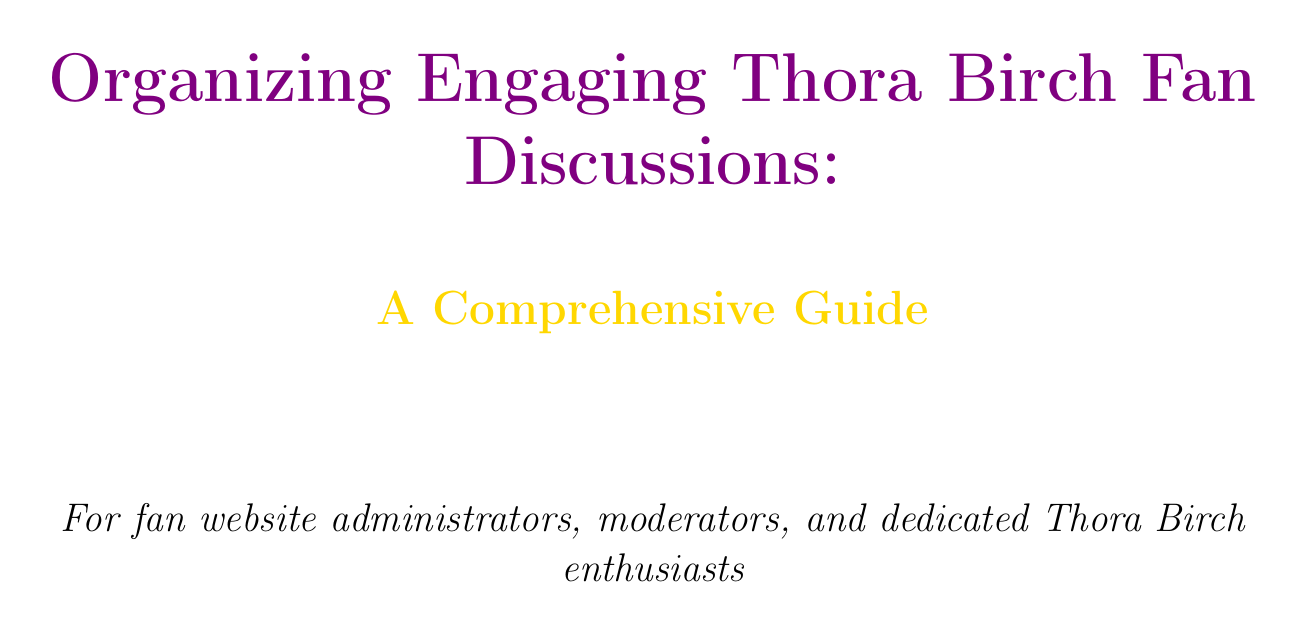what is the title of the manual? The title of the manual is presented at the beginning of the document as "Organizing Engaging Thora Birch Fan Discussions: A Comprehensive Guide".
Answer: Organizing Engaging Thora Birch Fan Discussions: A Comprehensive Guide who is the target audience of the manual? The target audience is specified in the introduction section as "fan website administrators, moderators, and dedicated Thora Birch enthusiasts."
Answer: fan website administrators, moderators, and dedicated Thora Birch enthusiasts what platform is recommended for virtual watch parties? The document discusses popular options for hosting virtual watch parties, mentioning "Discord, Zoom, and Teleparty".
Answer: Discord, Zoom, and Teleparty name one film discussed in Thora Birch's filmography preparation section. The section suggests creating a list of Thora Birch's films, mentioning "Dungeons & Dragons" and "Petunia" among others.
Answer: Dungeons & Dragons what activity is suggested for post-discussion engagement? The manual suggests "Collaborative Fan Projects" as an activity to engage fans after the discussions.
Answer: Collaborative Fan Projects how can moderators manage difficult conversations? The document outlines strategies for moderators to address controversial topics, emphasizing "Managing Difficult Conversations".
Answer: Managing Difficult Conversations what is one of the facilitation techniques mentioned? The manual lists "Active Listening and Engagement" as a technique to encourage participation from members.
Answer: Active Listening and Engagement which social media platforms are suggested for fan engagement? The document provides tips for "Instagram and Twitter" as social media platforms for Thora Birch fan engagement.
Answer: Instagram and Twitter what type of event is suggested for future planning? The manual encourages gathering feedback for "themed events around specific films" as part of planning future activities.
Answer: themed events around specific films 